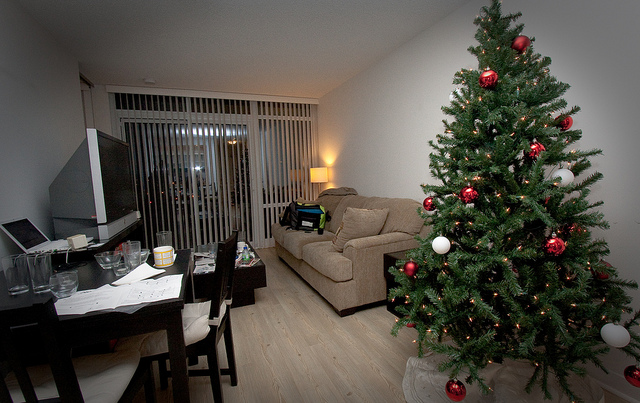What holiday is likely being celebrated in this image? Given the decorated tree with ornaments and the overall feeling in the room, it seems that Christmas is being celebrated. What decorations can you see on the Christmas tree? The Christmas tree is adorned with a variety of red ornaments, including round baubles, and there's a string of white lights wrapped around it. 